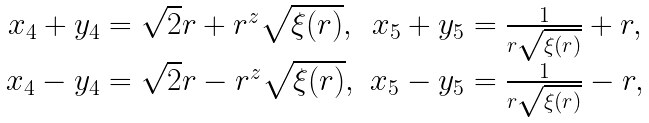Convert formula to latex. <formula><loc_0><loc_0><loc_500><loc_500>\begin{array} { c c } x _ { 4 } + y _ { 4 } = \sqrt { 2 } r + r ^ { z } \sqrt { \xi ( r ) } , & x _ { 5 } + y _ { 5 } = \frac { 1 } { r \sqrt { \xi ( r ) } } + r , \\ x _ { 4 } - y _ { 4 } = \sqrt { 2 } r - r ^ { z } \sqrt { \xi ( r ) } , & x _ { 5 } - y _ { 5 } = \frac { 1 } { r \sqrt { \xi ( r ) } } - r , \end{array}</formula> 